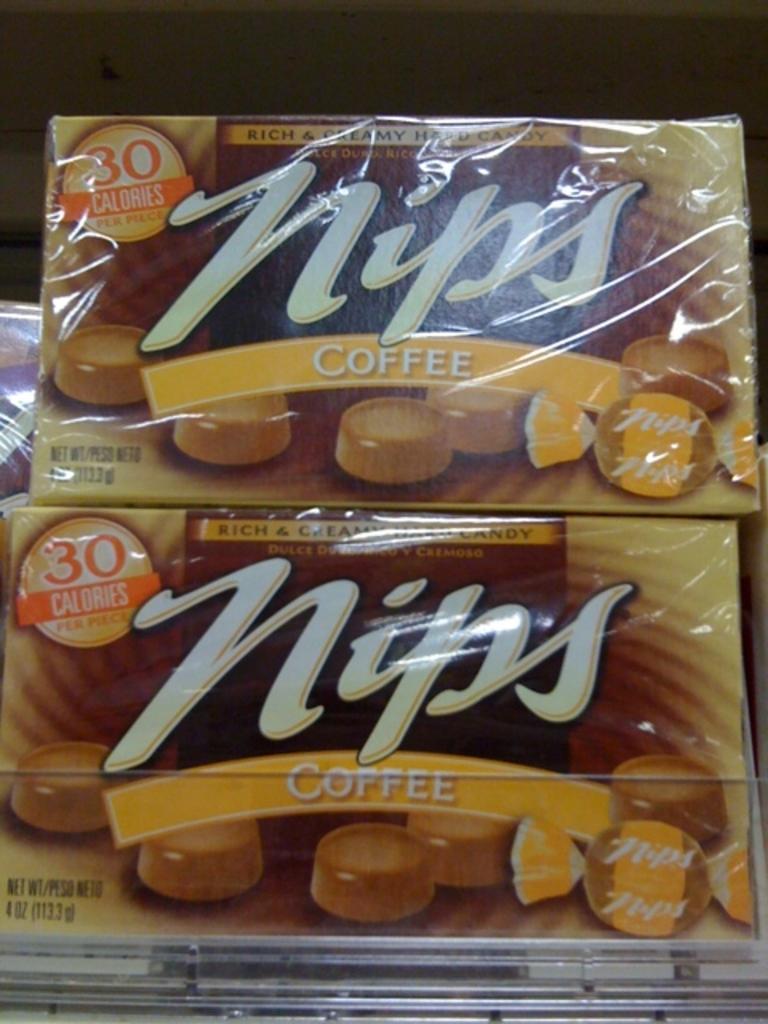In one or two sentences, can you explain what this image depicts? In the image there are two coffee bar chocolate packs on a shelf. 